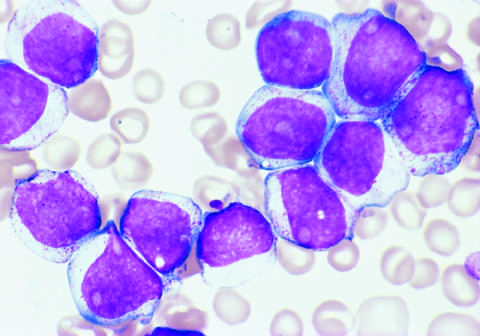what are the tumor cells positive for?
Answer the question using a single word or phrase. The stem cell marker cd34 and myeloid lineage specific markers cd33 and cd15 